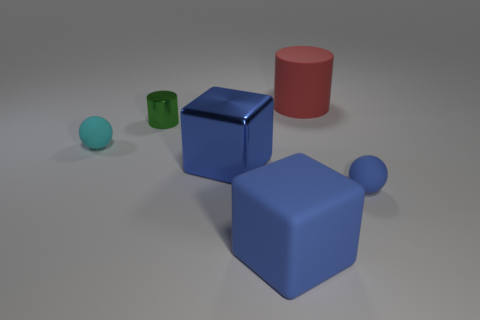Are there any other things that are the same material as the green cylinder?
Offer a very short reply. Yes. What number of small objects are either green shiny objects or cyan matte objects?
Ensure brevity in your answer.  2. What number of things are either cyan objects in front of the red thing or red cylinders?
Keep it short and to the point. 2. Do the shiny cylinder and the big shiny thing have the same color?
Give a very brief answer. No. What number of other things are the same shape as the large red object?
Make the answer very short. 1. How many yellow objects are big matte objects or balls?
Provide a short and direct response. 0. There is a big cube that is made of the same material as the red cylinder; what is its color?
Ensure brevity in your answer.  Blue. Do the cube behind the tiny blue thing and the blue object that is on the right side of the big blue matte block have the same material?
Keep it short and to the point. No. What is the size of the sphere that is the same color as the shiny block?
Ensure brevity in your answer.  Small. What is the ball right of the red thing made of?
Make the answer very short. Rubber. 